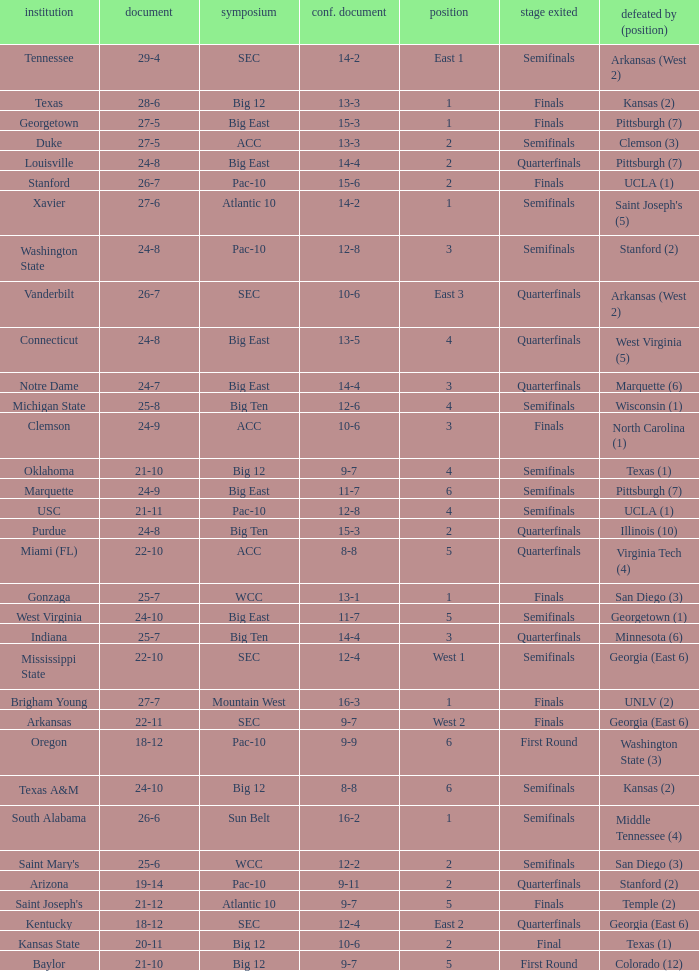Name the round eliminated where conference record is 12-6 Semifinals. 